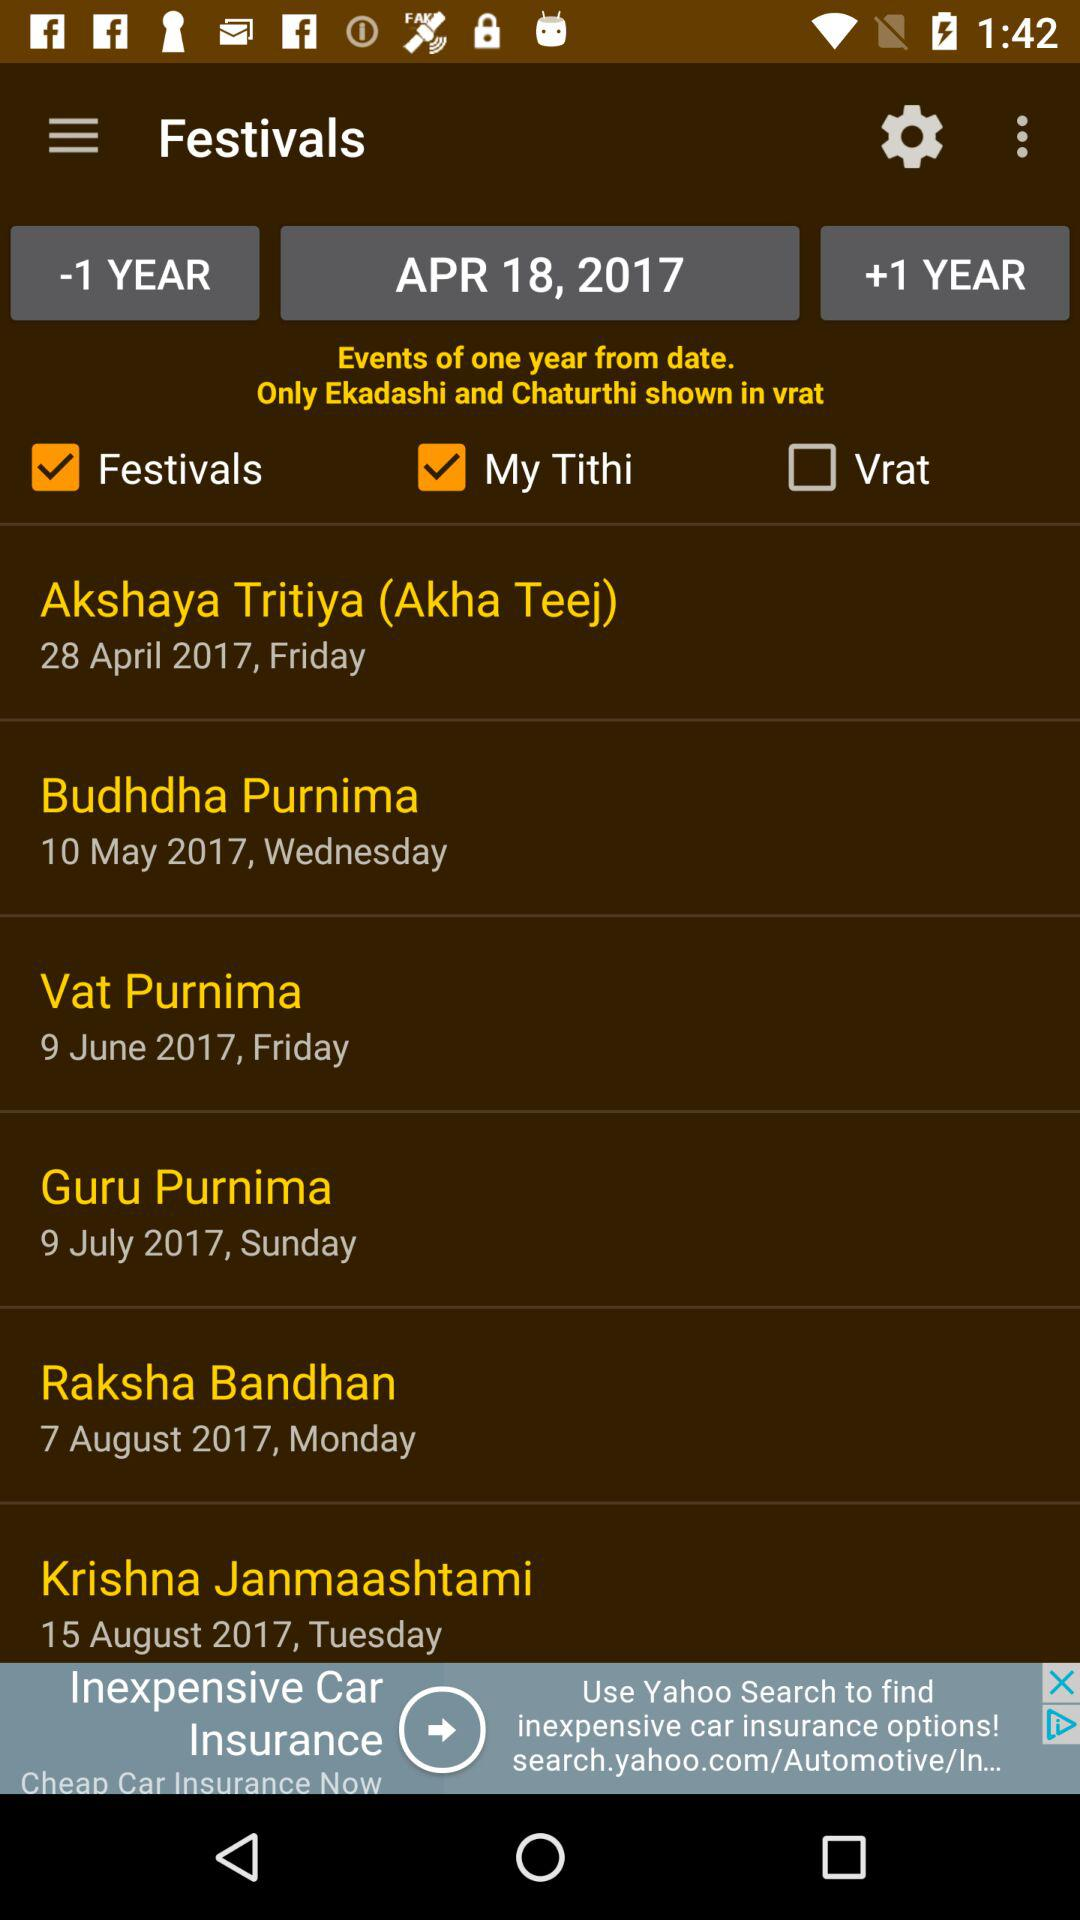What is the selected date? The selected date is April 18, 2017. 